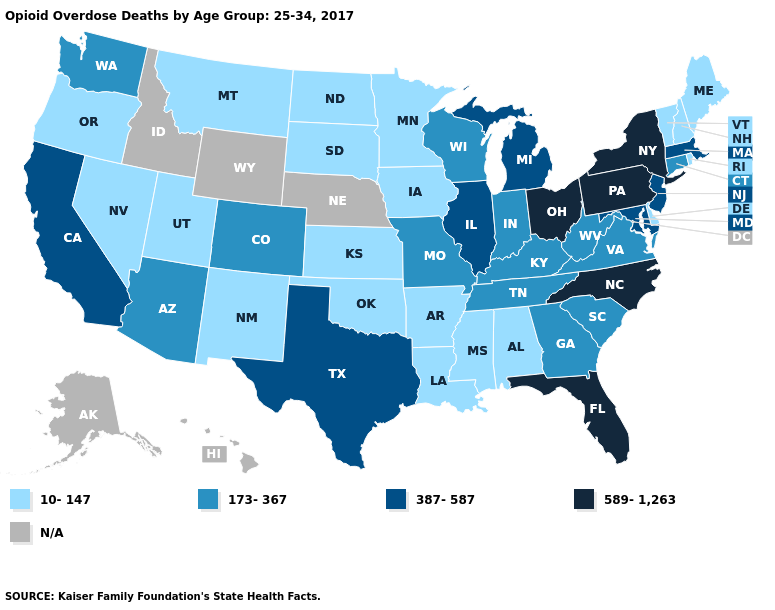What is the lowest value in the USA?
Be succinct. 10-147. Name the states that have a value in the range 10-147?
Answer briefly. Alabama, Arkansas, Delaware, Iowa, Kansas, Louisiana, Maine, Minnesota, Mississippi, Montana, Nevada, New Hampshire, New Mexico, North Dakota, Oklahoma, Oregon, Rhode Island, South Dakota, Utah, Vermont. What is the highest value in states that border Wyoming?
Answer briefly. 173-367. Does the map have missing data?
Keep it brief. Yes. What is the value of Vermont?
Keep it brief. 10-147. Which states have the highest value in the USA?
Give a very brief answer. Florida, New York, North Carolina, Ohio, Pennsylvania. Name the states that have a value in the range 10-147?
Keep it brief. Alabama, Arkansas, Delaware, Iowa, Kansas, Louisiana, Maine, Minnesota, Mississippi, Montana, Nevada, New Hampshire, New Mexico, North Dakota, Oklahoma, Oregon, Rhode Island, South Dakota, Utah, Vermont. What is the value of Colorado?
Concise answer only. 173-367. Does the first symbol in the legend represent the smallest category?
Answer briefly. Yes. Which states have the lowest value in the USA?
Give a very brief answer. Alabama, Arkansas, Delaware, Iowa, Kansas, Louisiana, Maine, Minnesota, Mississippi, Montana, Nevada, New Hampshire, New Mexico, North Dakota, Oklahoma, Oregon, Rhode Island, South Dakota, Utah, Vermont. Name the states that have a value in the range 173-367?
Quick response, please. Arizona, Colorado, Connecticut, Georgia, Indiana, Kentucky, Missouri, South Carolina, Tennessee, Virginia, Washington, West Virginia, Wisconsin. What is the value of Oregon?
Answer briefly. 10-147. How many symbols are there in the legend?
Short answer required. 5. What is the highest value in states that border Iowa?
Concise answer only. 387-587. 